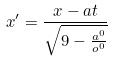Convert formula to latex. <formula><loc_0><loc_0><loc_500><loc_500>x ^ { \prime } = \frac { x - a t } { \sqrt { 9 - \frac { a ^ { 0 } } { o ^ { 0 } } } }</formula> 